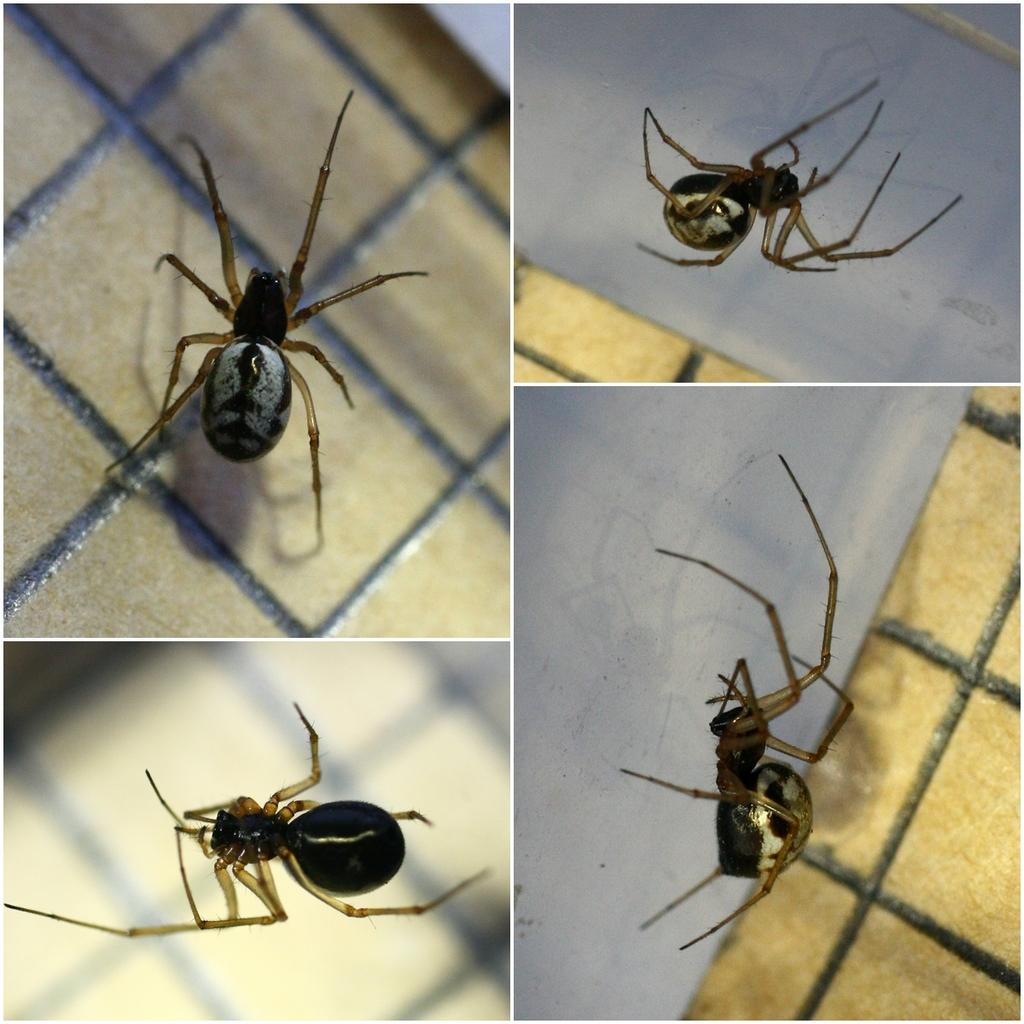What type of artwork is depicted in the image? The image is a collage. What subject is consistently present throughout the collage? A spider is present in all images within the collage. What type of sack is being carried by the spider in the image? There is no sack being carried by the spider in the image; the spider is the only subject present in each image. 